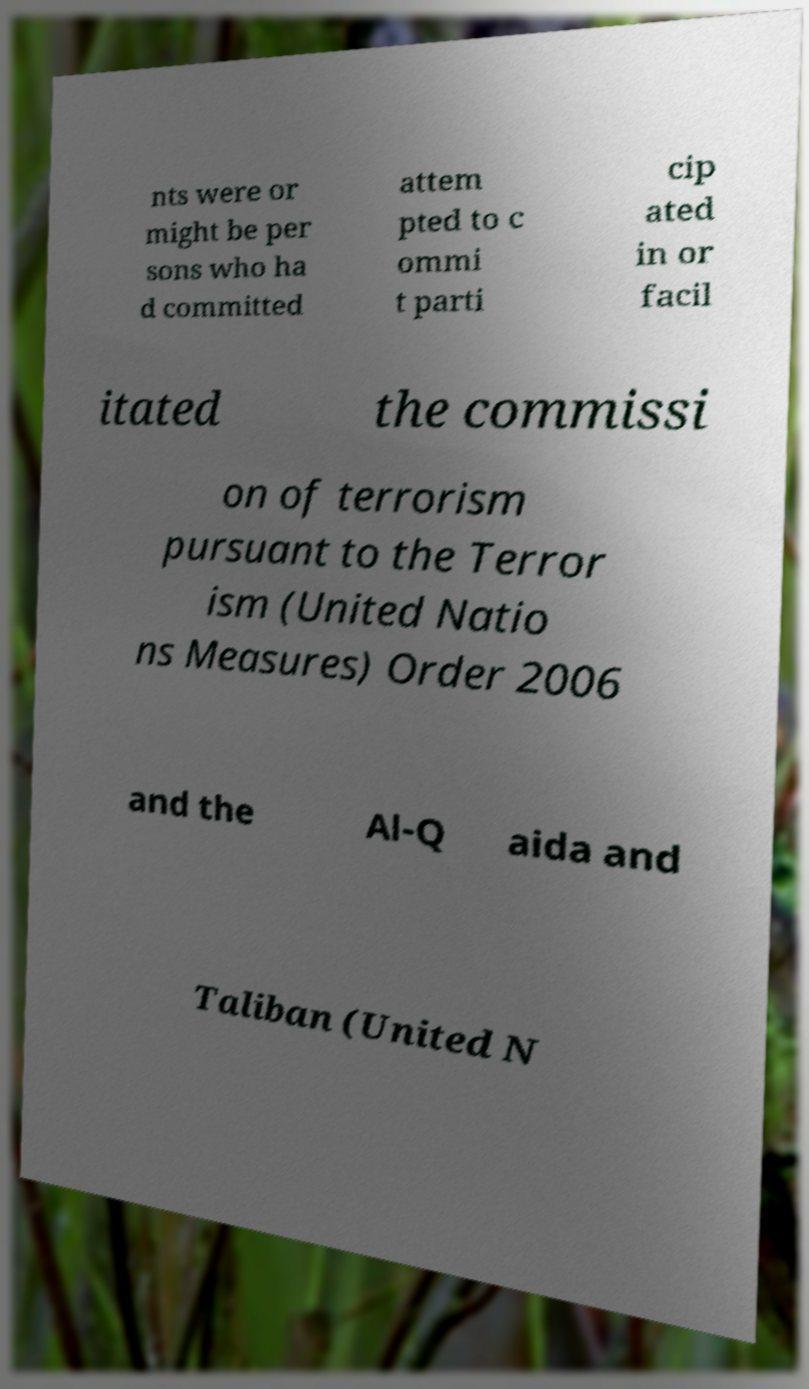There's text embedded in this image that I need extracted. Can you transcribe it verbatim? nts were or might be per sons who ha d committed attem pted to c ommi t parti cip ated in or facil itated the commissi on of terrorism pursuant to the Terror ism (United Natio ns Measures) Order 2006 and the Al-Q aida and Taliban (United N 